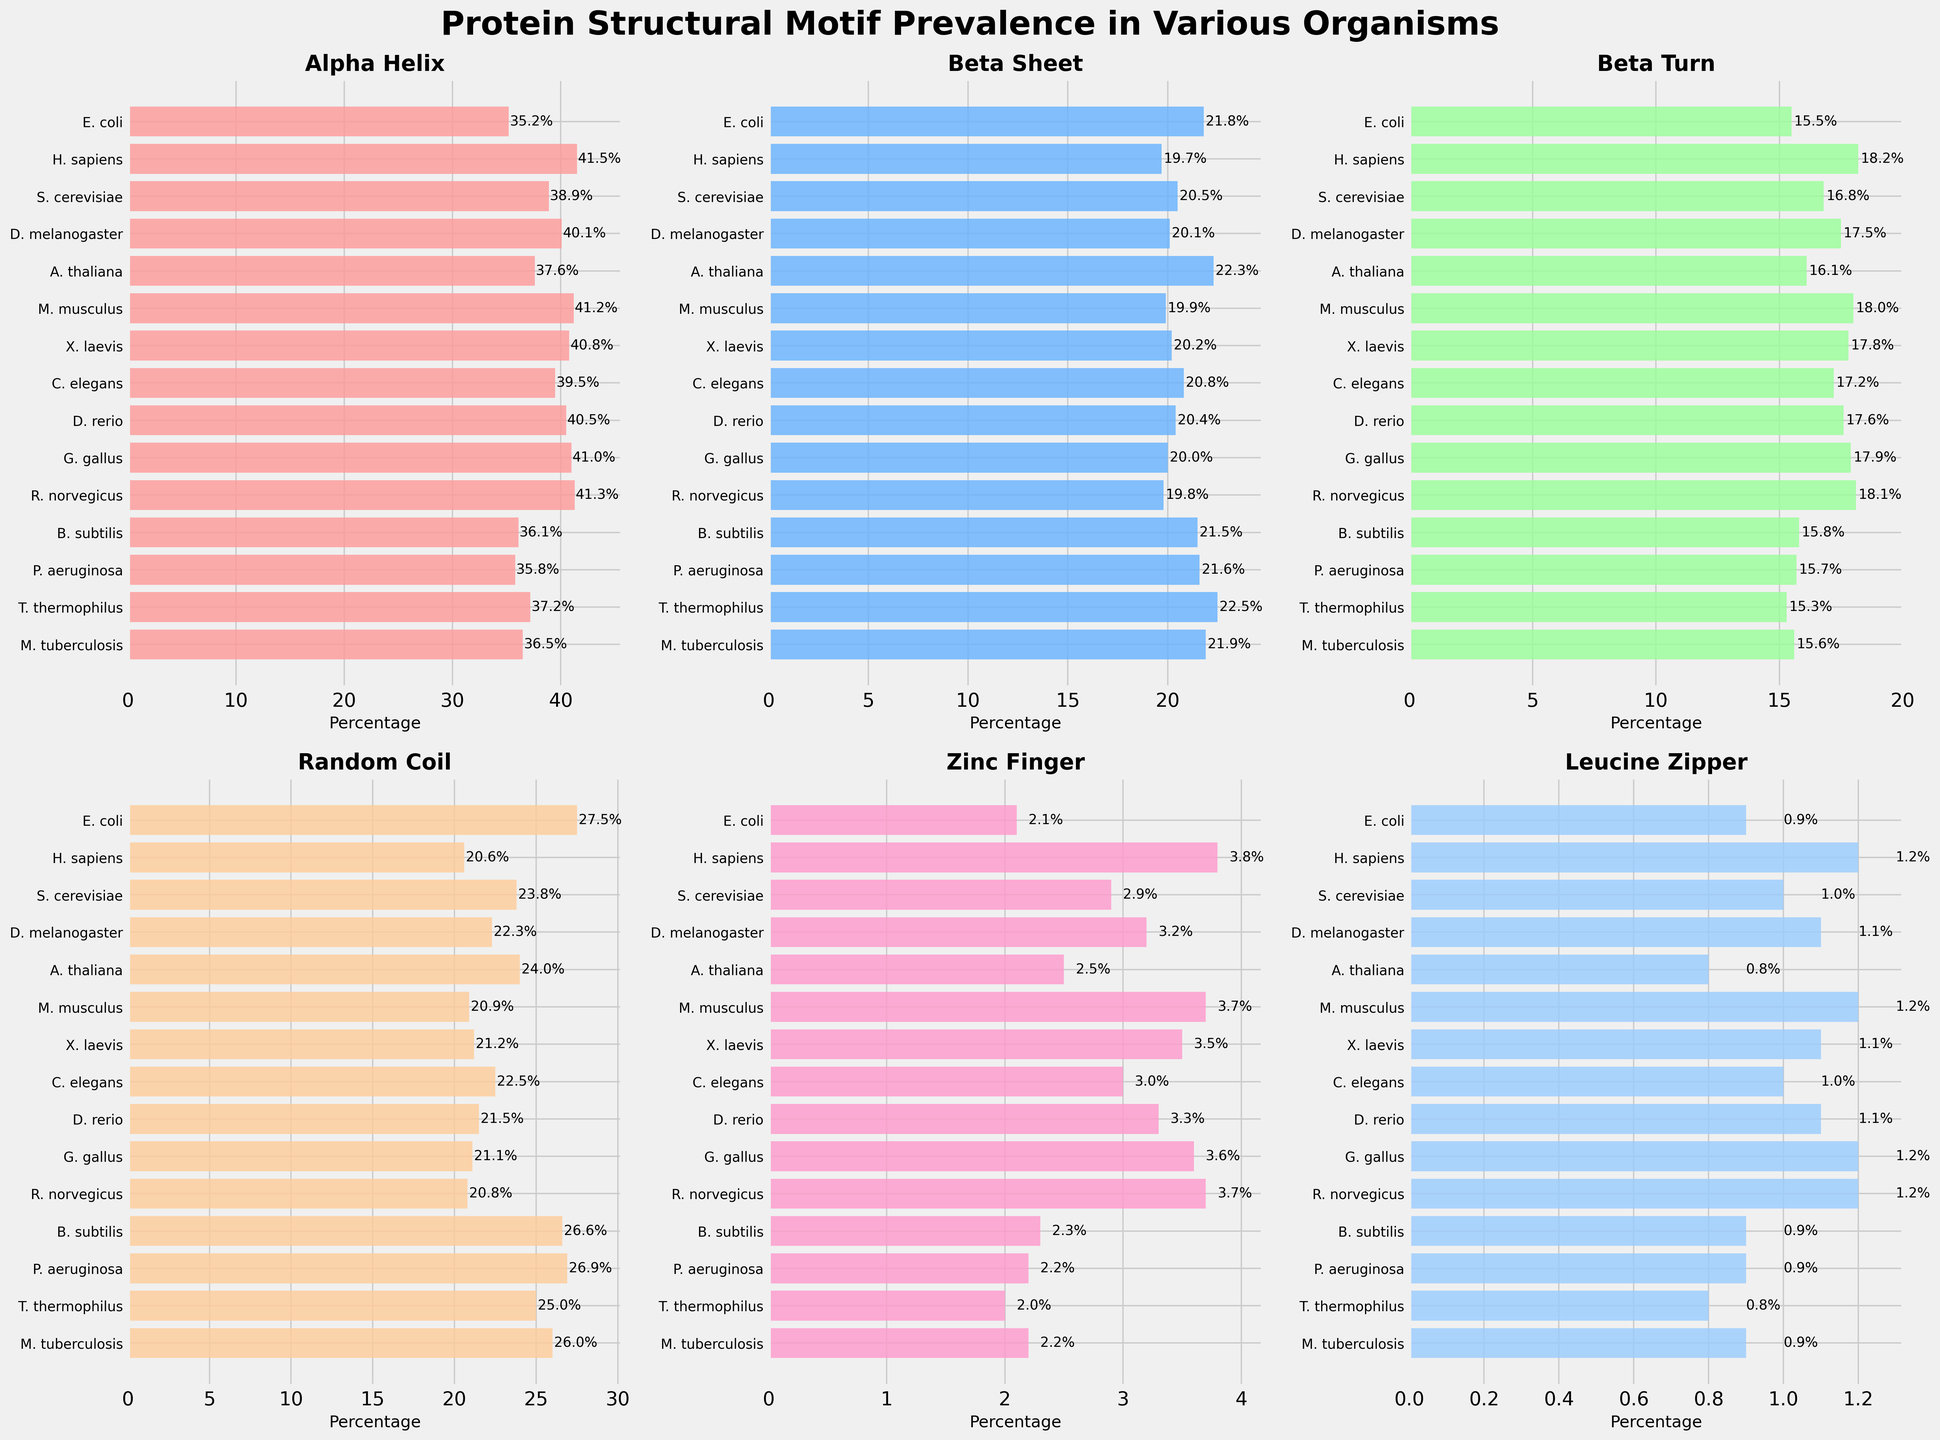What's the prevalence of Alpha Helix structures in H. sapiens compared to E. coli? To find this, look at the bar heights for Alpha Helix in H. sapiens and E. coli. H. sapiens has a prevalence of 41.5%, while E. coli has 35.2%. Therefore, H. sapiens has a higher prevalence.
Answer: H. sapiens has higher prevalence Which organism has the highest prevalence of Beta Turn structures? Look for the tallest bar in the Beta Turn subplot. H. sapiens has the highest beta turn prevalence at 18.2%.
Answer: H. sapiens Is the prevalence of Random Coil structures higher in B. subtilis or P. aeruginosa? Compare the lengths of the bars for Random Coil for both organisms. B. subtilis has 26.6% while P. aeruginosa has 26.9%. Thus, P. aeruginosa has a slightly higher prevalence.
Answer: P. aeruginosa How does the prevalence of Leucine Zipper structures in R. norvegicus compare to X. laevis? Check the Leucine Zipper subplot and compare the bars for R. norvegicus (1.2%) and X. laevis (1.1%). R. norvegicus has a slightly higher prevalence.
Answer: R. norvegicus has higher prevalence What's the difference in the prevalence of Beta Sheet structures between A. thaliana and D. melanogaster? Look at the heights for Beta Sheet in both A. thaliana (22.3%) and D. melanogaster (20.1%). The difference is 22.3% - 20.1% = 2.2%.
Answer: 2.2% Which structural motif has the highest average prevalence across all organisms? Calculate the average prevalence for each motif by summing their percentages across all organisms and dividing by 15. Alpha Helix has an average prevalence of (sum of all Alpha Helix percentages)/15 = 38.74%, which is the highest.
Answer: Alpha Helix Which organism has the lowest prevalence of Zinc Finger structures? Look for the shortest bar in the Zinc Finger subplot. T. thermophilus has the lowest prevalence at 2.0%.
Answer: T. thermophilus Which two organisms have an equal prevalence of Beta Turn structures? Match the bar lengths in Beta Turn subplot. E. coli and M. tuberculosis both have a prevalence of 15.5% and 15.6%, respectively, so none have equal values.
Answer: None What's the combined prevalence of Alpha Helix and Beta Sheet structures in M. musculus? Add the prevalences of Alpha Helix (41.2%) and Beta Sheet (19.9%) in M. musculus. The total is 41.2% + 19.9% = 61.1%.
Answer: 61.1% Among the given organisms, which structural motif shows the least variation in prevalence? To find this, observe which motif bars differ the least in height. Beta Sheet ranges from around 19% to 22%, indicating it has the least variation in prevalence.
Answer: Beta Sheet 